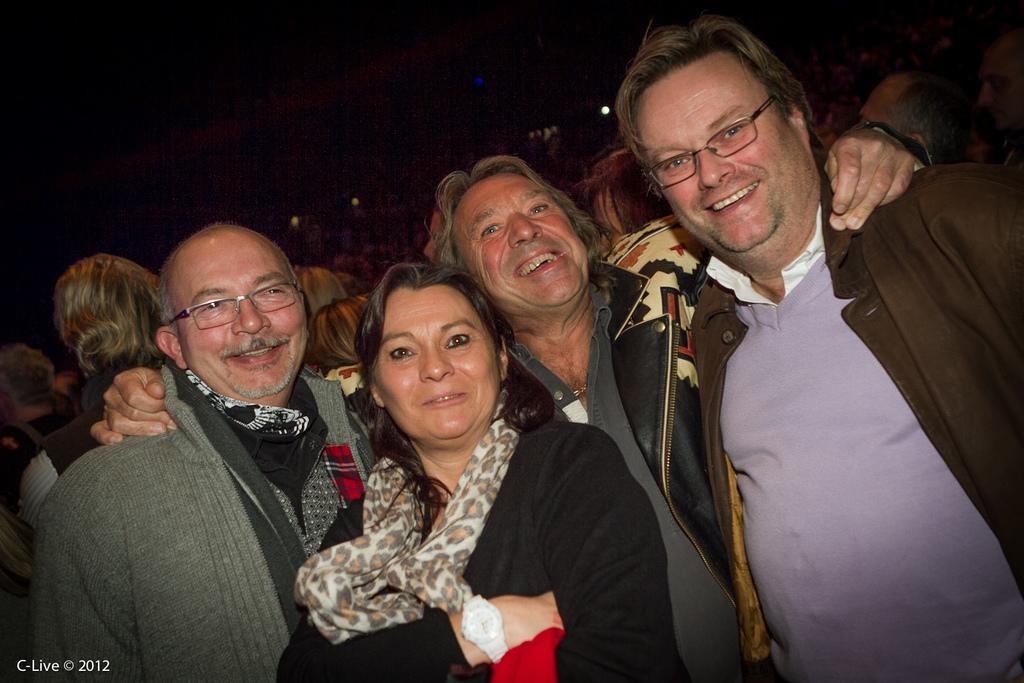What can be observed about the people in the image? There are people standing in the image, and some of them are wearing sunglasses. How are the people feeling in the image? The people have smiles on their faces, indicating that they are happy or enjoying themselves. What else can be seen in the image besides the people? There are lights visible in the image, and there is text at the bottom left corner of the image. What type of cakes are being served at the event in the image? There is no mention of cakes or an event in the image; it only shows people standing with smiles on their faces. What is the tendency of the beetle in the image? There is no beetle present in the image. 